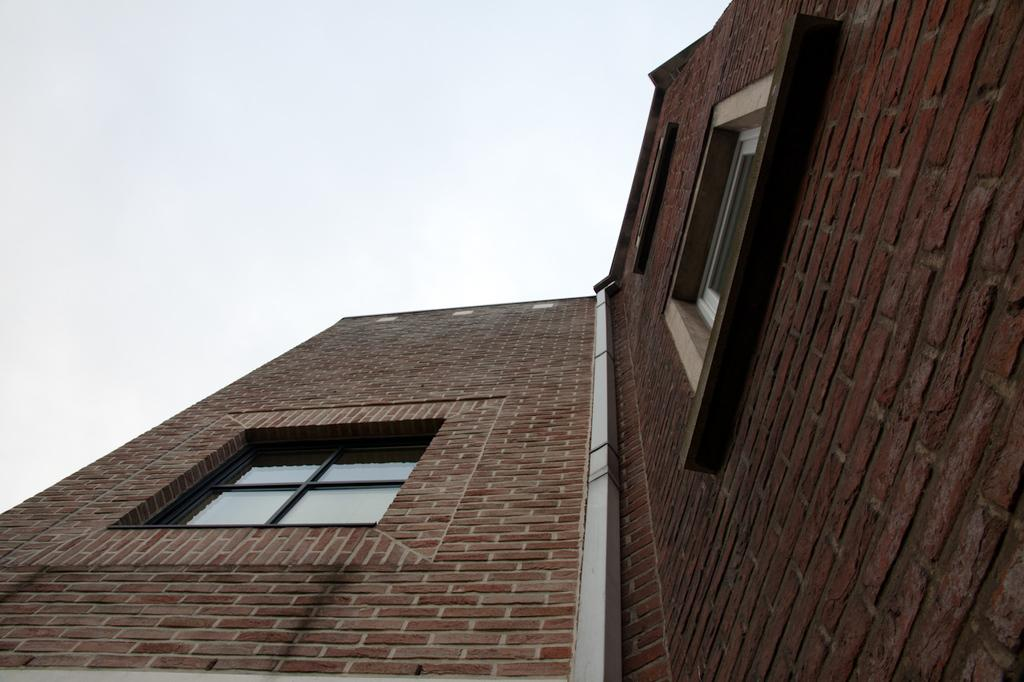What is the main subject of the image? The main subject of the image is a building. Can you describe the building in the image? The building has windows. What is the condition of the sky in the image? The sky is cloudy. What type of animal can be seen interacting with the building in the image? There is no animal present in the image, and therefore no such interaction can be observed. What is the purpose of the calculator in the image? There is no calculator present in the image. 